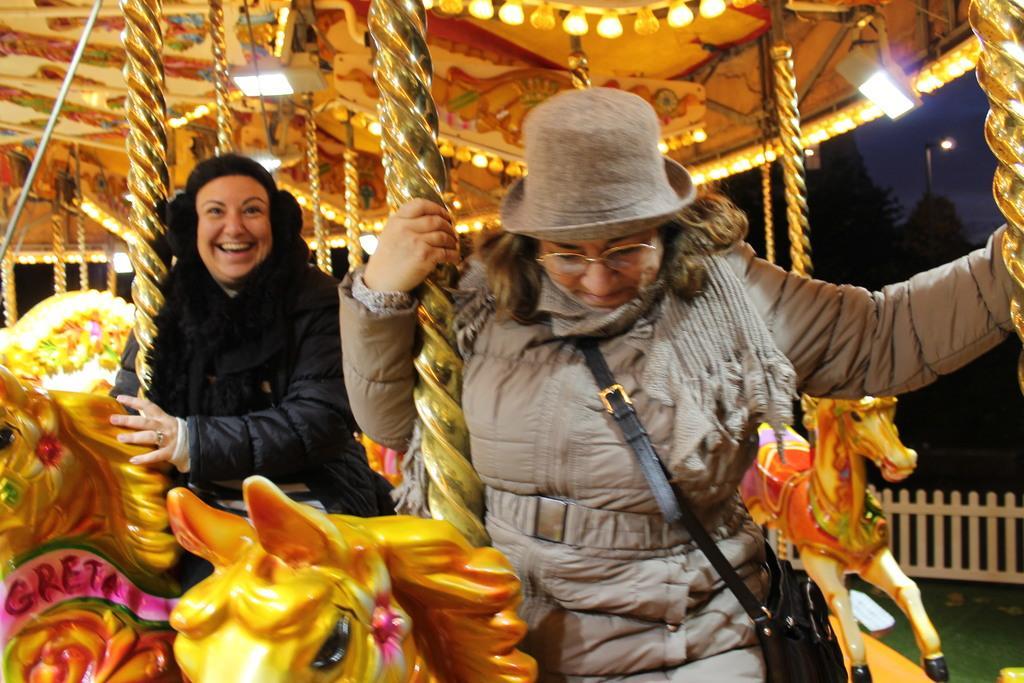Could you give a brief overview of what you see in this image? In this image, we can see two persons sitting on the merry-go-round seats. In the background, there are poles and lights. On the right side of the image, we can see the fence, street light, trees and sky. 